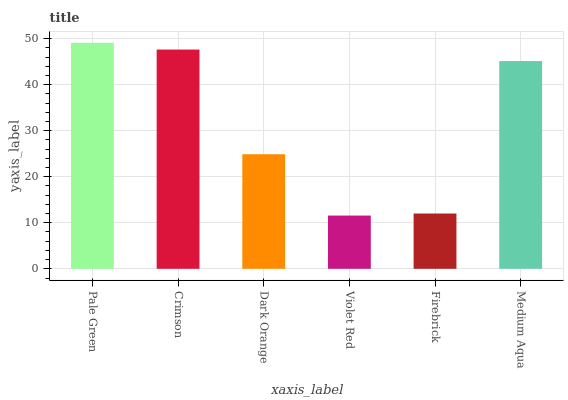Is Violet Red the minimum?
Answer yes or no. Yes. Is Pale Green the maximum?
Answer yes or no. Yes. Is Crimson the minimum?
Answer yes or no. No. Is Crimson the maximum?
Answer yes or no. No. Is Pale Green greater than Crimson?
Answer yes or no. Yes. Is Crimson less than Pale Green?
Answer yes or no. Yes. Is Crimson greater than Pale Green?
Answer yes or no. No. Is Pale Green less than Crimson?
Answer yes or no. No. Is Medium Aqua the high median?
Answer yes or no. Yes. Is Dark Orange the low median?
Answer yes or no. Yes. Is Firebrick the high median?
Answer yes or no. No. Is Crimson the low median?
Answer yes or no. No. 